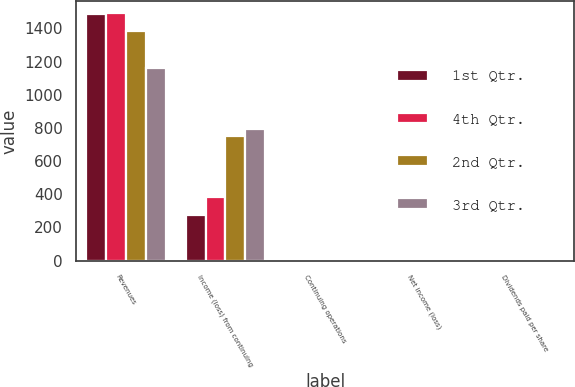Convert chart. <chart><loc_0><loc_0><loc_500><loc_500><stacked_bar_chart><ecel><fcel>Revenues<fcel>Income (loss) from continuing<fcel>Continuing operations<fcel>Net income (loss)<fcel>Dividends paid per share<nl><fcel>1st Qtr.<fcel>1484<fcel>276<fcel>0.41<fcel>0.41<fcel>0.21<nl><fcel>4th Qtr.<fcel>1490<fcel>386<fcel>0.57<fcel>0.57<fcel>0.21<nl><fcel>2nd Qtr.<fcel>1384<fcel>749<fcel>1.11<fcel>1.11<fcel>0.21<nl><fcel>3rd Qtr.<fcel>1164<fcel>793<fcel>1.17<fcel>1.17<fcel>0.05<nl></chart> 